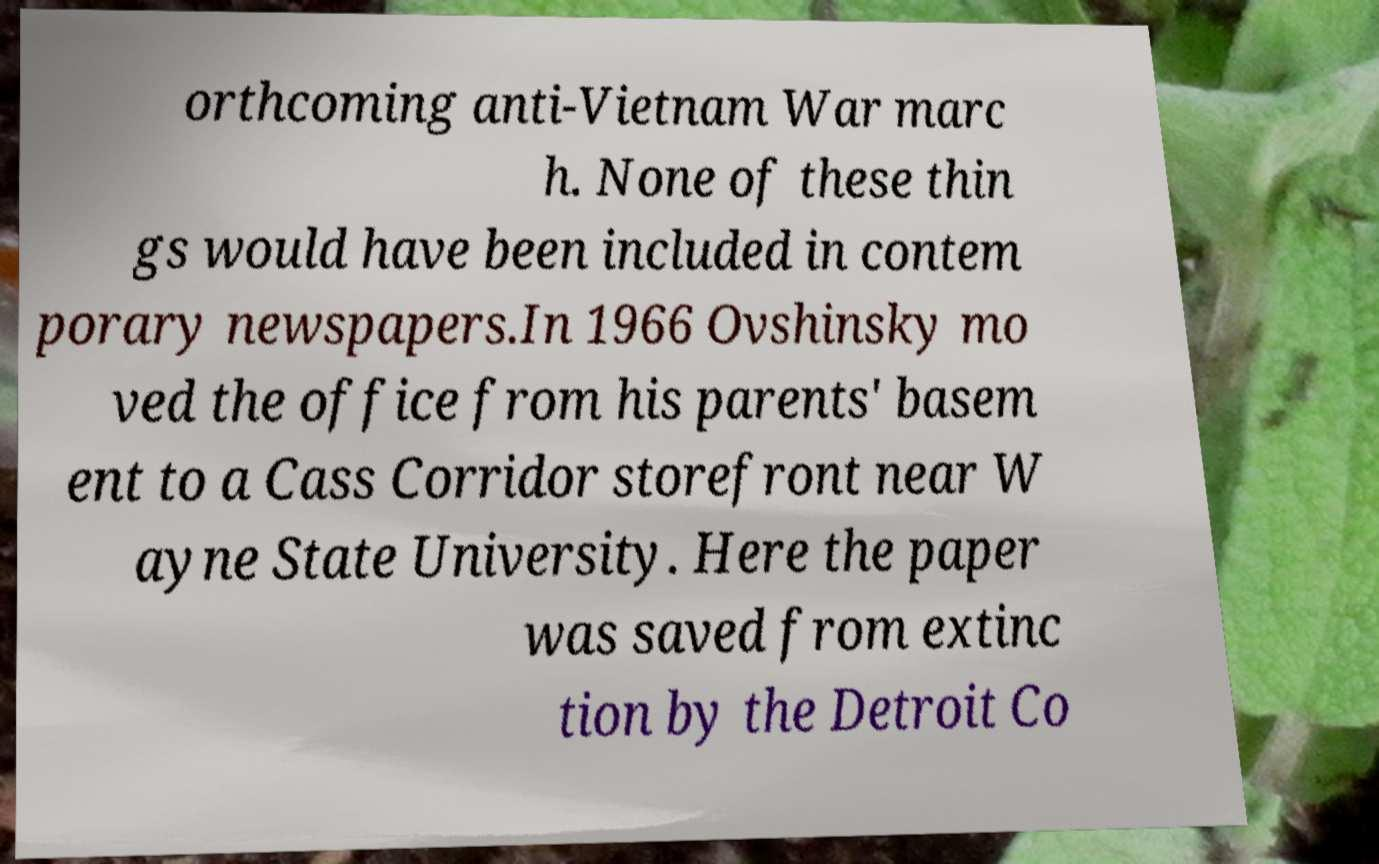For documentation purposes, I need the text within this image transcribed. Could you provide that? orthcoming anti-Vietnam War marc h. None of these thin gs would have been included in contem porary newspapers.In 1966 Ovshinsky mo ved the office from his parents' basem ent to a Cass Corridor storefront near W ayne State University. Here the paper was saved from extinc tion by the Detroit Co 